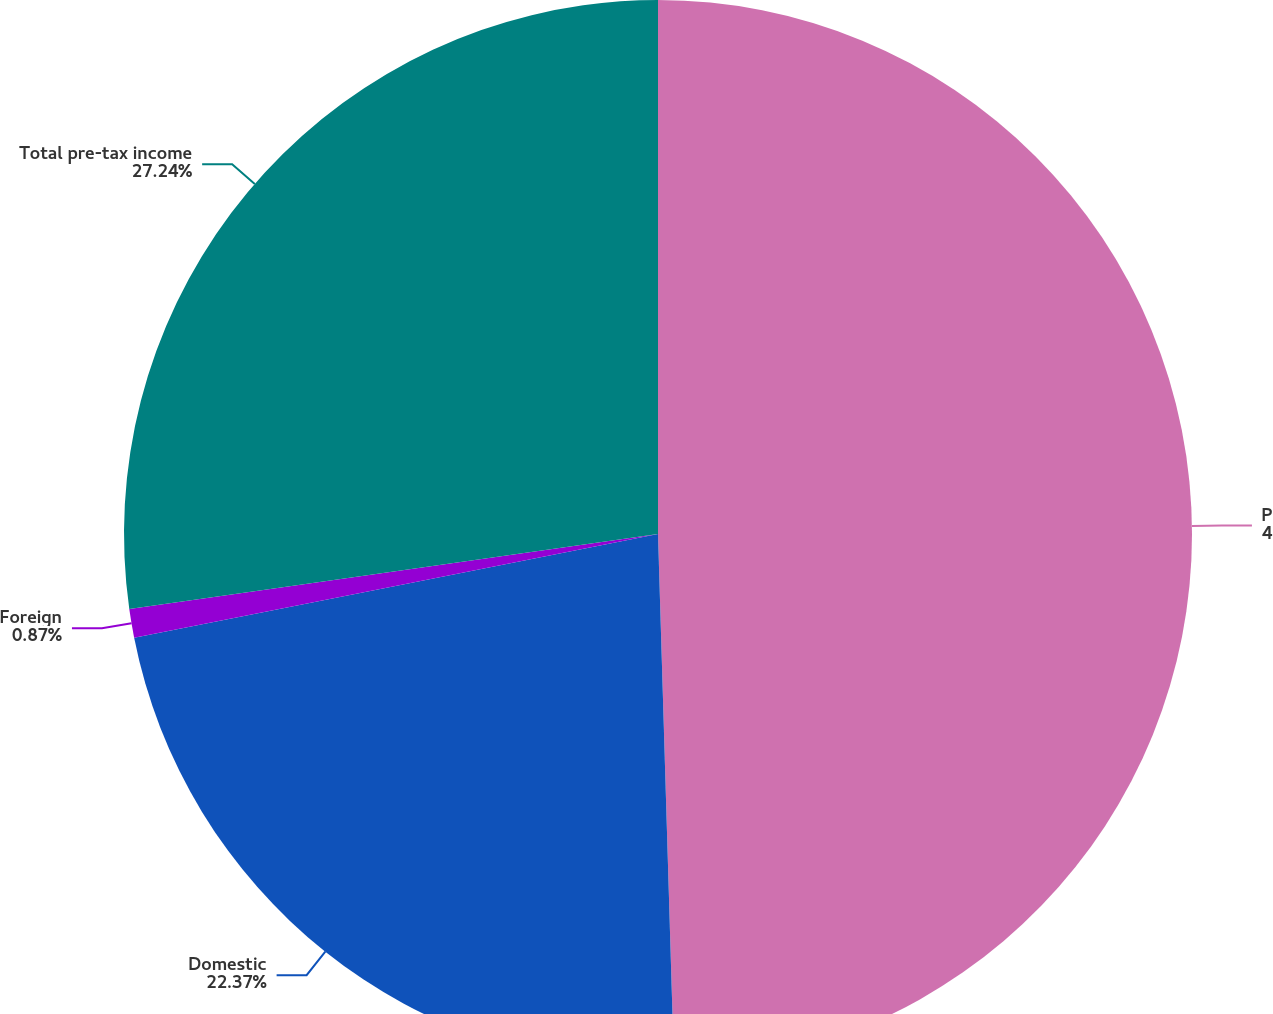Convert chart. <chart><loc_0><loc_0><loc_500><loc_500><pie_chart><fcel>Pre-tax income<fcel>Domestic<fcel>Foreign<fcel>Total pre-tax income<nl><fcel>49.52%<fcel>22.37%<fcel>0.87%<fcel>27.24%<nl></chart> 